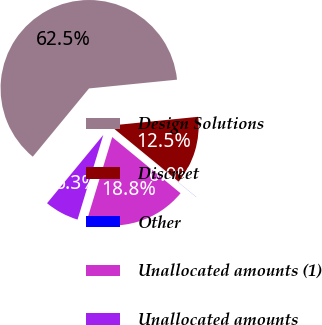Convert chart. <chart><loc_0><loc_0><loc_500><loc_500><pie_chart><fcel>Design Solutions<fcel>Discreet<fcel>Other<fcel>Unallocated amounts (1)<fcel>Unallocated amounts<nl><fcel>62.45%<fcel>12.51%<fcel>0.02%<fcel>18.75%<fcel>6.27%<nl></chart> 